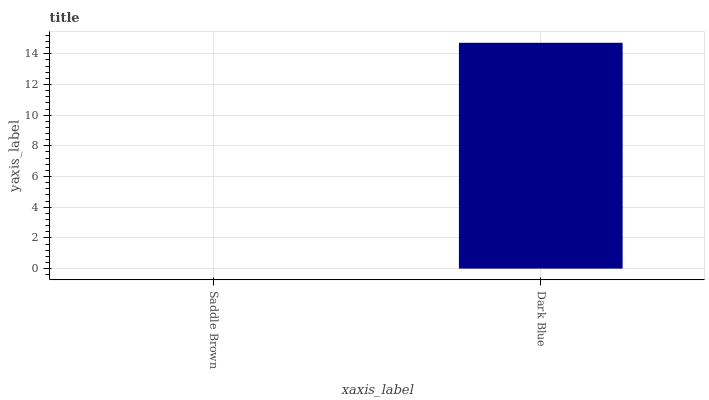Is Saddle Brown the minimum?
Answer yes or no. Yes. Is Dark Blue the maximum?
Answer yes or no. Yes. Is Dark Blue the minimum?
Answer yes or no. No. Is Dark Blue greater than Saddle Brown?
Answer yes or no. Yes. Is Saddle Brown less than Dark Blue?
Answer yes or no. Yes. Is Saddle Brown greater than Dark Blue?
Answer yes or no. No. Is Dark Blue less than Saddle Brown?
Answer yes or no. No. Is Dark Blue the high median?
Answer yes or no. Yes. Is Saddle Brown the low median?
Answer yes or no. Yes. Is Saddle Brown the high median?
Answer yes or no. No. Is Dark Blue the low median?
Answer yes or no. No. 